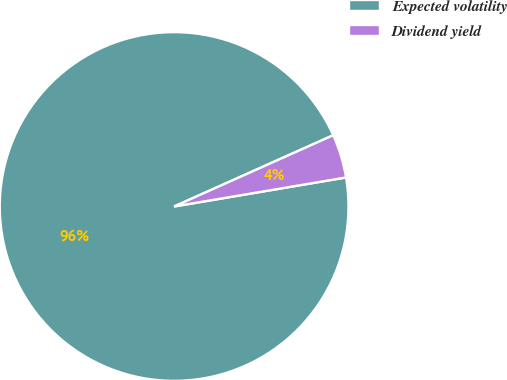<chart> <loc_0><loc_0><loc_500><loc_500><pie_chart><fcel>Expected volatility<fcel>Dividend yield<nl><fcel>95.96%<fcel>4.04%<nl></chart> 